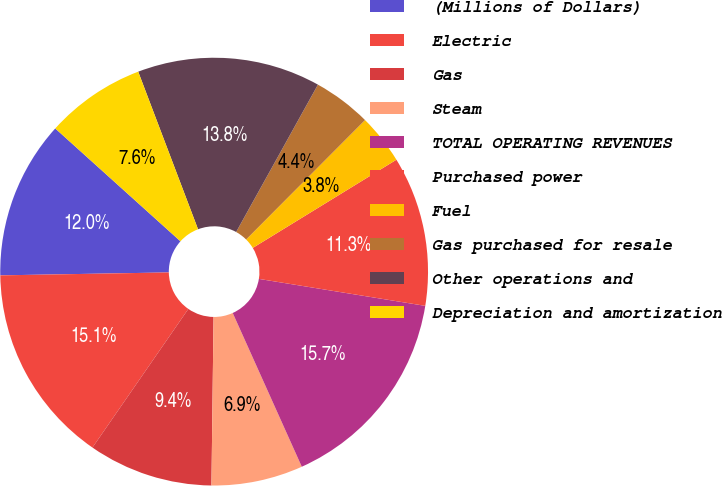Convert chart. <chart><loc_0><loc_0><loc_500><loc_500><pie_chart><fcel>(Millions of Dollars)<fcel>Electric<fcel>Gas<fcel>Steam<fcel>TOTAL OPERATING REVENUES<fcel>Purchased power<fcel>Fuel<fcel>Gas purchased for resale<fcel>Other operations and<fcel>Depreciation and amortization<nl><fcel>11.95%<fcel>15.09%<fcel>9.43%<fcel>6.92%<fcel>15.72%<fcel>11.32%<fcel>3.77%<fcel>4.4%<fcel>13.84%<fcel>7.55%<nl></chart> 